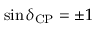<formula> <loc_0><loc_0><loc_500><loc_500>\sin \delta _ { C P } = \pm 1</formula> 